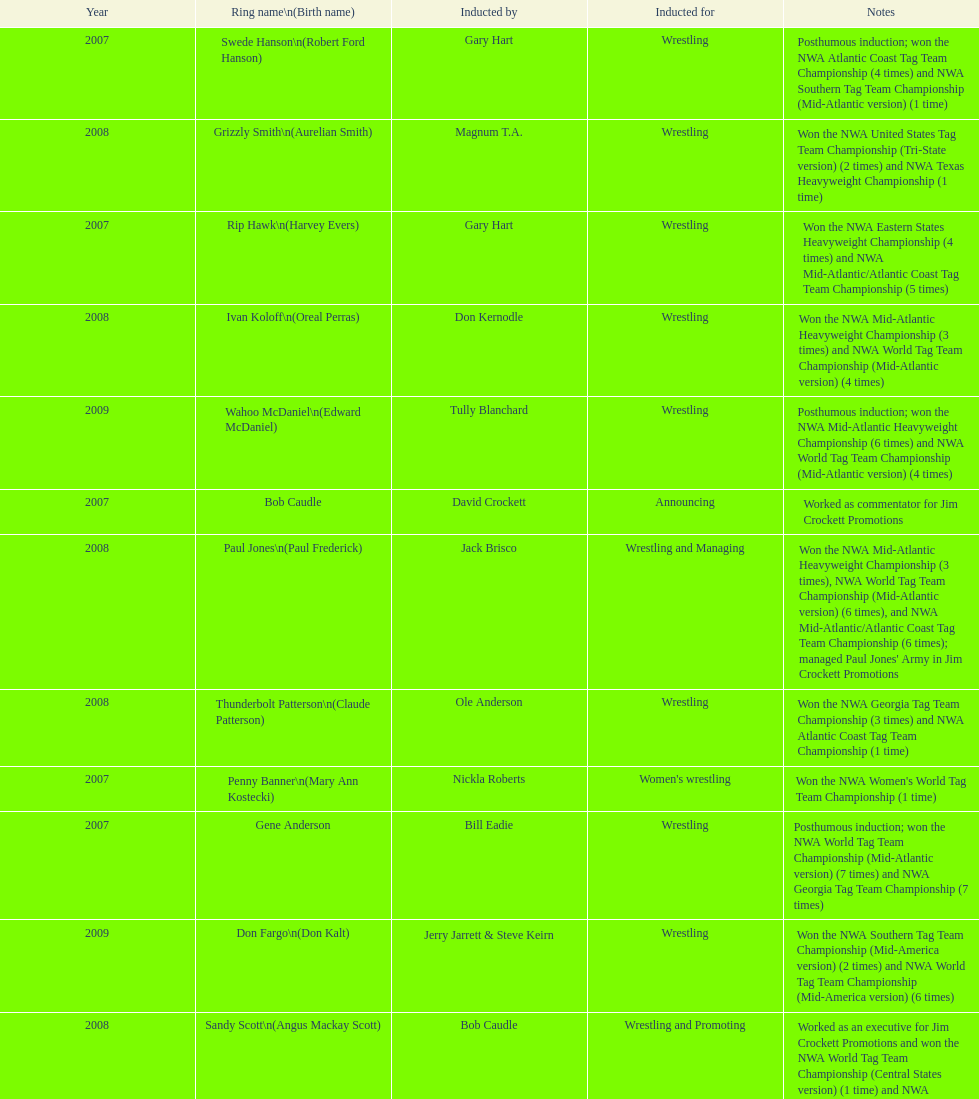Who holds the record for the most nwa southern tag team wins (mid-america version)? Jackie Fargo. 